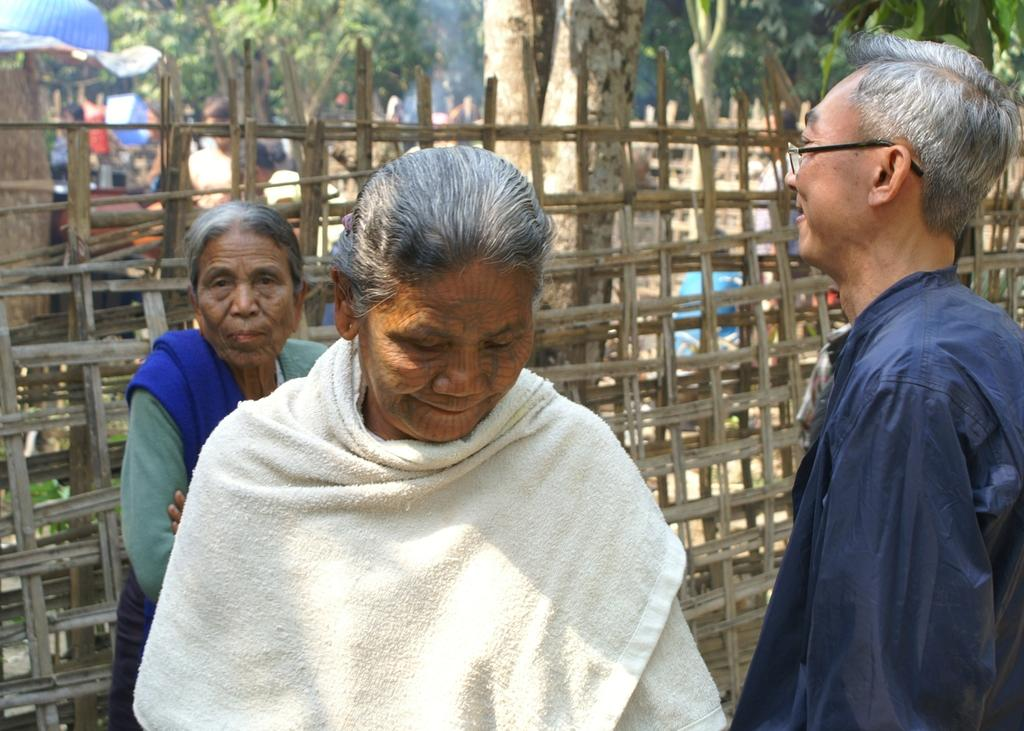How many individuals are present in the image? There are many people in the image. What type of barrier can be seen in the image? There is a fence in the image. What type of natural elements are present in the image? There are many trees in the image. What is the distance between the people and the fence in the image? The provided facts do not give information about the distance between the people and the fence, so it cannot be determined from the image. 